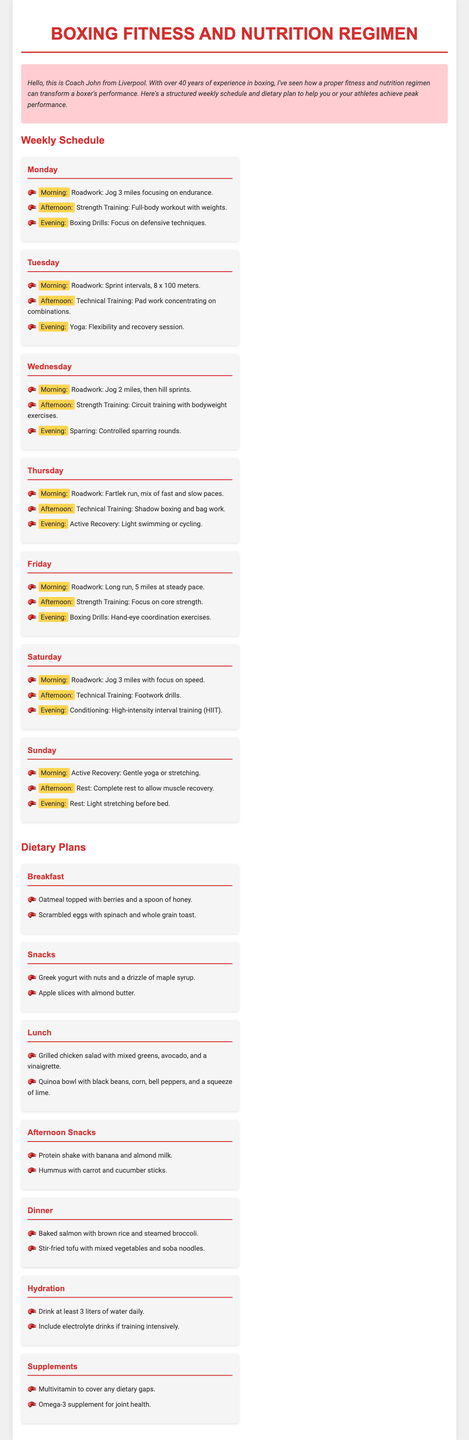What is the first meal listed for breakfast? The first meal listed under breakfast is oatmeal topped with berries and a spoon of honey.
Answer: oatmeal topped with berries and a spoon of honey How many miles are to be jogged on Monday morning? On Monday morning, the schedule indicates to jog 3 miles.
Answer: 3 miles What type of training is scheduled for Tuesday evening? The training scheduled for Tuesday evening is yoga, specifically for flexibility and recovery.
Answer: Yoga Which day includes hill sprints in the morning session? Wednesday includes hill sprints in the morning session after jogging 2 miles.
Answer: Wednesday What is recommended as a drink for hydration? The document mentions drinking at least 3 liters of water daily as a hydration recommendation.
Answer: 3 liters of water How many total strength training sessions are there in the week? There are four strength training sessions listed across the week.
Answer: 4 What recovery activity is scheduled for Sunday afternoon? On Sunday afternoon, complete rest is scheduled to allow muscle recovery.
Answer: Complete rest Which day focuses on technical training with combinations? Tuesday focuses on technical training with pad work concentrating on combinations.
Answer: Tuesday What type of exercises are performed in the evening on Friday? The evening on Friday includes hand-eye coordination exercises as boxing drills.
Answer: hand-eye coordination exercises 